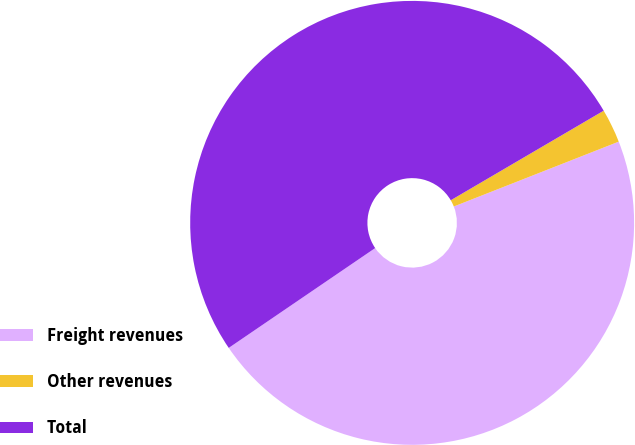Convert chart to OTSL. <chart><loc_0><loc_0><loc_500><loc_500><pie_chart><fcel>Freight revenues<fcel>Other revenues<fcel>Total<nl><fcel>46.44%<fcel>2.47%<fcel>51.09%<nl></chart> 